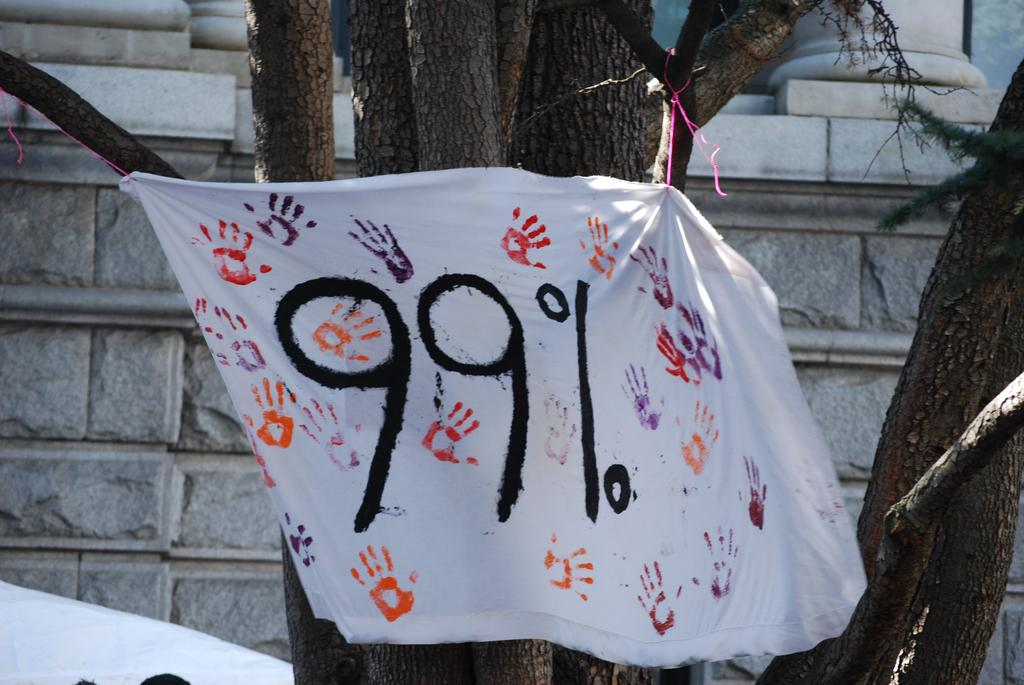What is located in the center of the image? There are trees and a cloth in the center of the image. What can be seen on the cloth? Two numbers are visible on the cloth, and there is some paint on it. What is visible in the background of the image? There is a wall and a few other objects in the background of the image. Can you see a hill in the background of the image? There is no hill visible in the background of the image. What type of sheet is covering the trees in the image? There is no sheet covering the trees in the image; the trees are not covered by any fabric. 